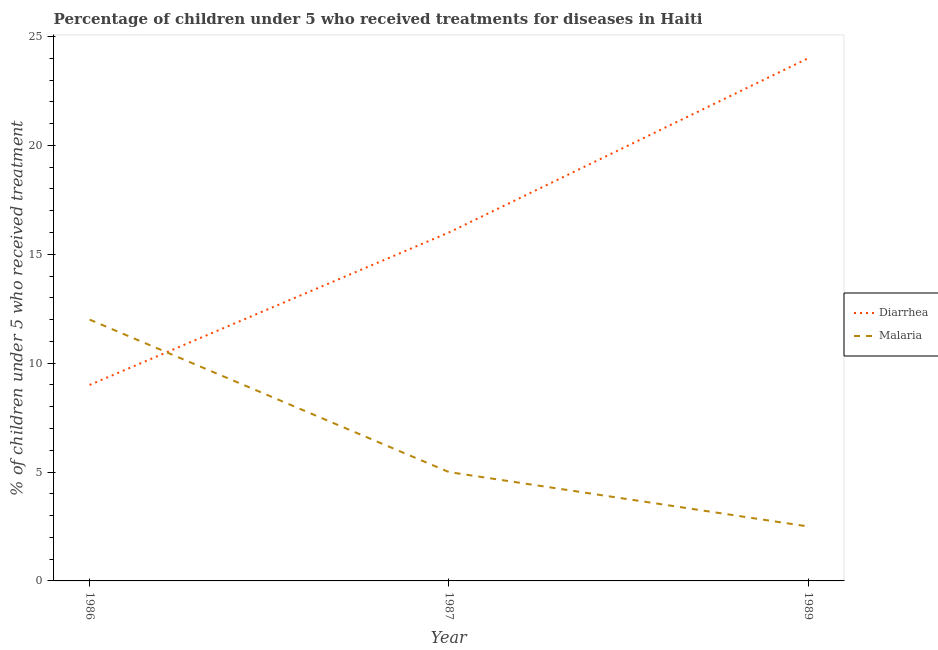What is the percentage of children who received treatment for diarrhoea in 1987?
Give a very brief answer. 16. Across all years, what is the maximum percentage of children who received treatment for diarrhoea?
Your response must be concise. 24. Across all years, what is the minimum percentage of children who received treatment for malaria?
Make the answer very short. 2.5. In which year was the percentage of children who received treatment for diarrhoea minimum?
Make the answer very short. 1986. What is the total percentage of children who received treatment for malaria in the graph?
Provide a succinct answer. 19.5. What is the difference between the percentage of children who received treatment for malaria in 1986 and that in 1989?
Provide a short and direct response. 9.5. What is the difference between the percentage of children who received treatment for diarrhoea in 1989 and the percentage of children who received treatment for malaria in 1986?
Make the answer very short. 12. What is the average percentage of children who received treatment for diarrhoea per year?
Provide a succinct answer. 16.33. What is the ratio of the percentage of children who received treatment for diarrhoea in 1986 to that in 1987?
Your answer should be very brief. 0.56. Is the percentage of children who received treatment for malaria in 1987 less than that in 1989?
Provide a short and direct response. No. What is the difference between the highest and the lowest percentage of children who received treatment for diarrhoea?
Provide a short and direct response. 15. Does the percentage of children who received treatment for malaria monotonically increase over the years?
Your response must be concise. No. Is the percentage of children who received treatment for diarrhoea strictly greater than the percentage of children who received treatment for malaria over the years?
Your answer should be compact. No. Is the percentage of children who received treatment for diarrhoea strictly less than the percentage of children who received treatment for malaria over the years?
Provide a succinct answer. No. How many lines are there?
Offer a terse response. 2. What is the difference between two consecutive major ticks on the Y-axis?
Ensure brevity in your answer.  5. Are the values on the major ticks of Y-axis written in scientific E-notation?
Provide a succinct answer. No. Does the graph contain any zero values?
Your answer should be very brief. No. Does the graph contain grids?
Offer a terse response. No. Where does the legend appear in the graph?
Keep it short and to the point. Center right. How many legend labels are there?
Provide a short and direct response. 2. How are the legend labels stacked?
Make the answer very short. Vertical. What is the title of the graph?
Give a very brief answer. Percentage of children under 5 who received treatments for diseases in Haiti. Does "Imports" appear as one of the legend labels in the graph?
Give a very brief answer. No. What is the label or title of the X-axis?
Your answer should be very brief. Year. What is the label or title of the Y-axis?
Your response must be concise. % of children under 5 who received treatment. What is the % of children under 5 who received treatment in Malaria in 1986?
Provide a succinct answer. 12. What is the % of children under 5 who received treatment of Malaria in 1987?
Your answer should be compact. 5. What is the % of children under 5 who received treatment in Malaria in 1989?
Give a very brief answer. 2.5. Across all years, what is the maximum % of children under 5 who received treatment in Diarrhea?
Ensure brevity in your answer.  24. Across all years, what is the minimum % of children under 5 who received treatment in Diarrhea?
Offer a very short reply. 9. What is the total % of children under 5 who received treatment in Malaria in the graph?
Provide a short and direct response. 19.5. What is the difference between the % of children under 5 who received treatment of Diarrhea in 1986 and that in 1987?
Offer a very short reply. -7. What is the difference between the % of children under 5 who received treatment of Diarrhea in 1986 and the % of children under 5 who received treatment of Malaria in 1989?
Ensure brevity in your answer.  6.5. What is the difference between the % of children under 5 who received treatment in Diarrhea in 1987 and the % of children under 5 who received treatment in Malaria in 1989?
Make the answer very short. 13.5. What is the average % of children under 5 who received treatment in Diarrhea per year?
Your answer should be very brief. 16.33. In the year 1987, what is the difference between the % of children under 5 who received treatment of Diarrhea and % of children under 5 who received treatment of Malaria?
Provide a short and direct response. 11. In the year 1989, what is the difference between the % of children under 5 who received treatment of Diarrhea and % of children under 5 who received treatment of Malaria?
Your answer should be very brief. 21.5. What is the ratio of the % of children under 5 who received treatment of Diarrhea in 1986 to that in 1987?
Offer a very short reply. 0.56. What is the ratio of the % of children under 5 who received treatment in Malaria in 1986 to that in 1987?
Your response must be concise. 2.4. What is the ratio of the % of children under 5 who received treatment in Diarrhea in 1986 to that in 1989?
Your response must be concise. 0.38. What is the ratio of the % of children under 5 who received treatment of Malaria in 1987 to that in 1989?
Your response must be concise. 2. What is the difference between the highest and the second highest % of children under 5 who received treatment of Diarrhea?
Make the answer very short. 8. What is the difference between the highest and the second highest % of children under 5 who received treatment in Malaria?
Provide a succinct answer. 7. What is the difference between the highest and the lowest % of children under 5 who received treatment of Malaria?
Offer a terse response. 9.5. 